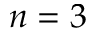Convert formula to latex. <formula><loc_0><loc_0><loc_500><loc_500>n = 3</formula> 